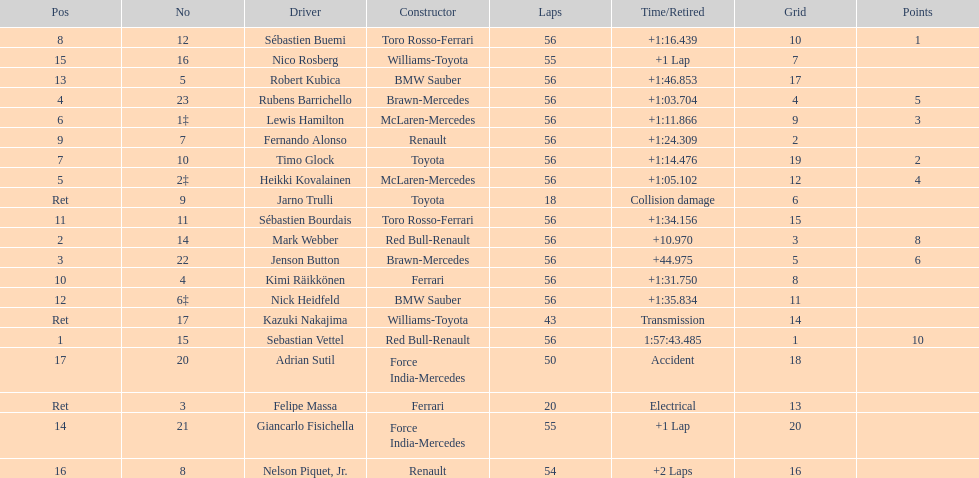How many drivers did not finish 56 laps? 7. 